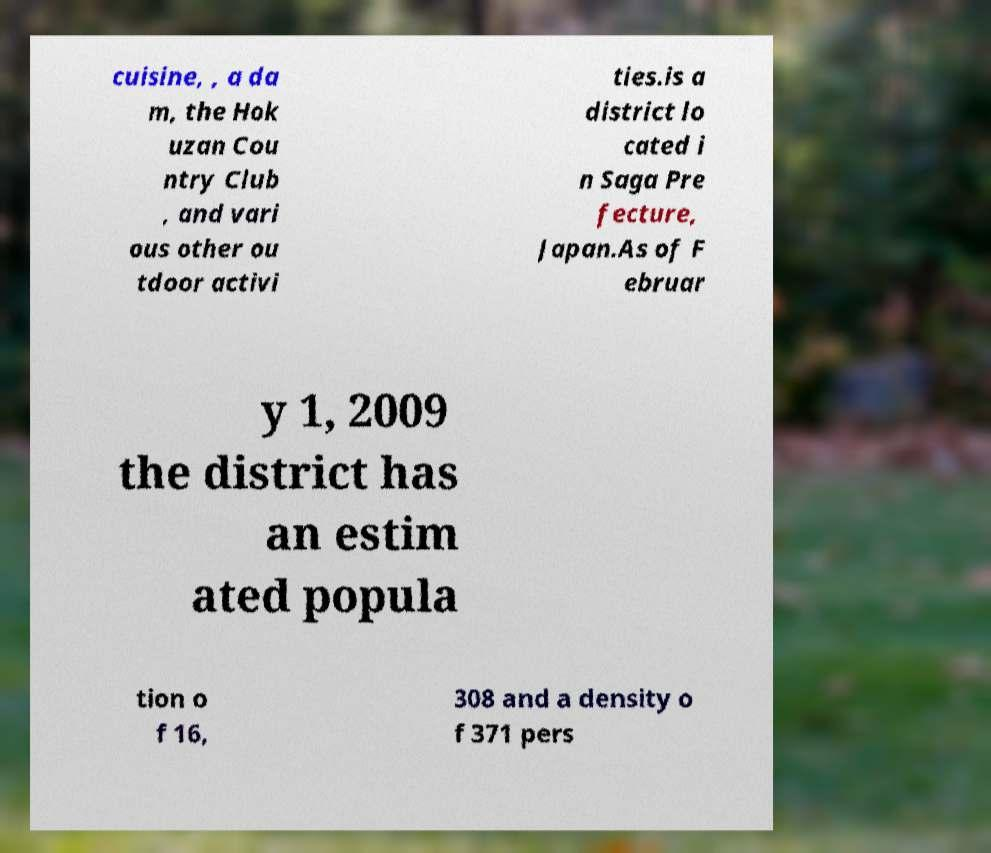Could you assist in decoding the text presented in this image and type it out clearly? cuisine, , a da m, the Hok uzan Cou ntry Club , and vari ous other ou tdoor activi ties.is a district lo cated i n Saga Pre fecture, Japan.As of F ebruar y 1, 2009 the district has an estim ated popula tion o f 16, 308 and a density o f 371 pers 